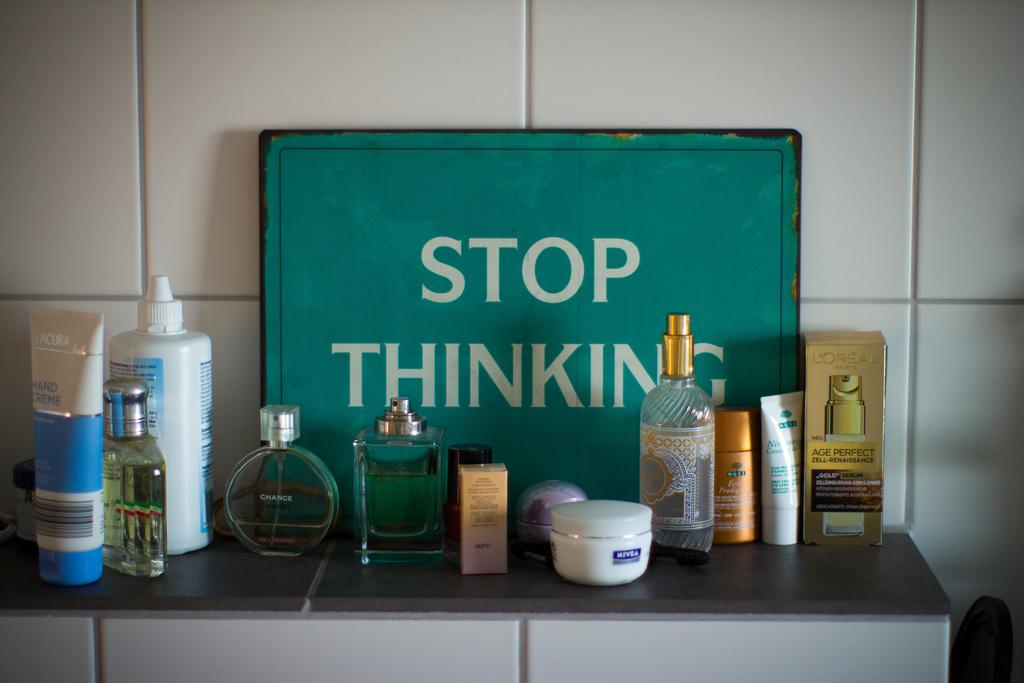Provide a one-sentence caption for the provided image. A number of toiletries stand on a tiled surface in front of a sign that says stop thinking. 